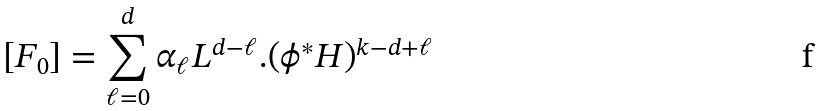<formula> <loc_0><loc_0><loc_500><loc_500>[ F _ { 0 } ] = \sum _ { \ell = 0 } ^ { d } \alpha _ { \ell } L ^ { d - \ell } . ( \phi ^ { * } H ) ^ { k - d + \ell }</formula> 